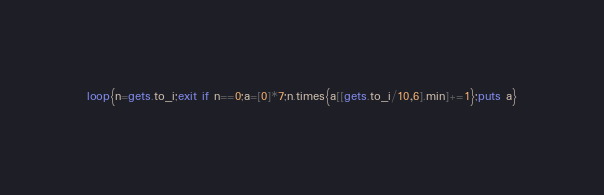<code> <loc_0><loc_0><loc_500><loc_500><_Ruby_>loop{n=gets.to_i;exit if n==0;a=[0]*7;n.times{a[[gets.to_i/10,6].min]+=1};puts a}
</code> 